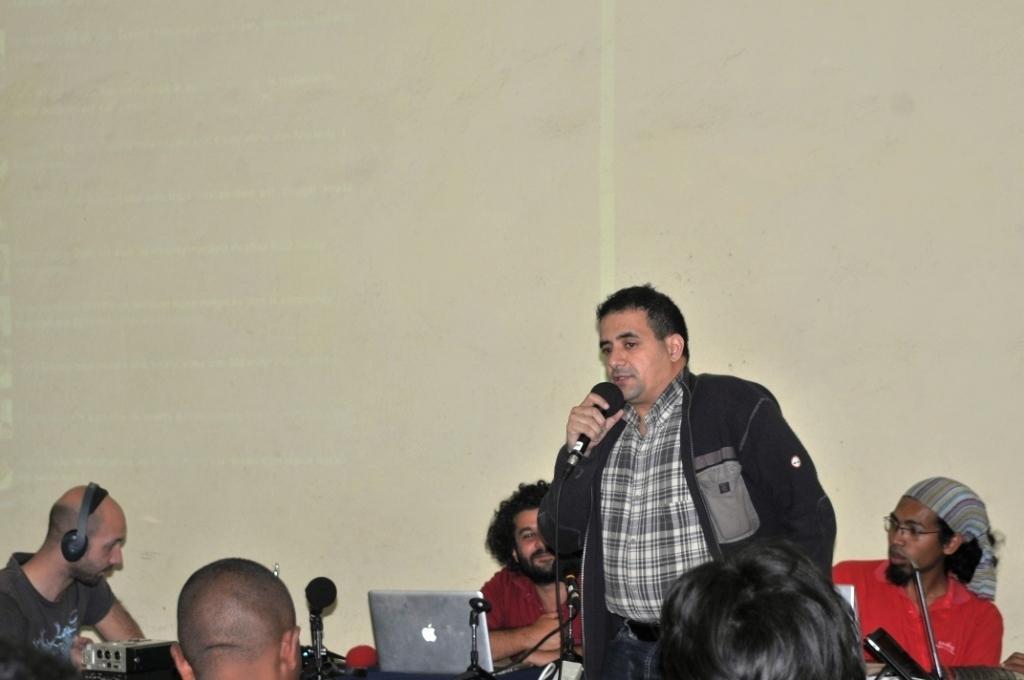In one or two sentences, can you explain what this image depicts? In this image, there are a few people. Among them, we can see a person holding a microphone. We can also see some laptops, microphones and some objects. We can also see the wall. 